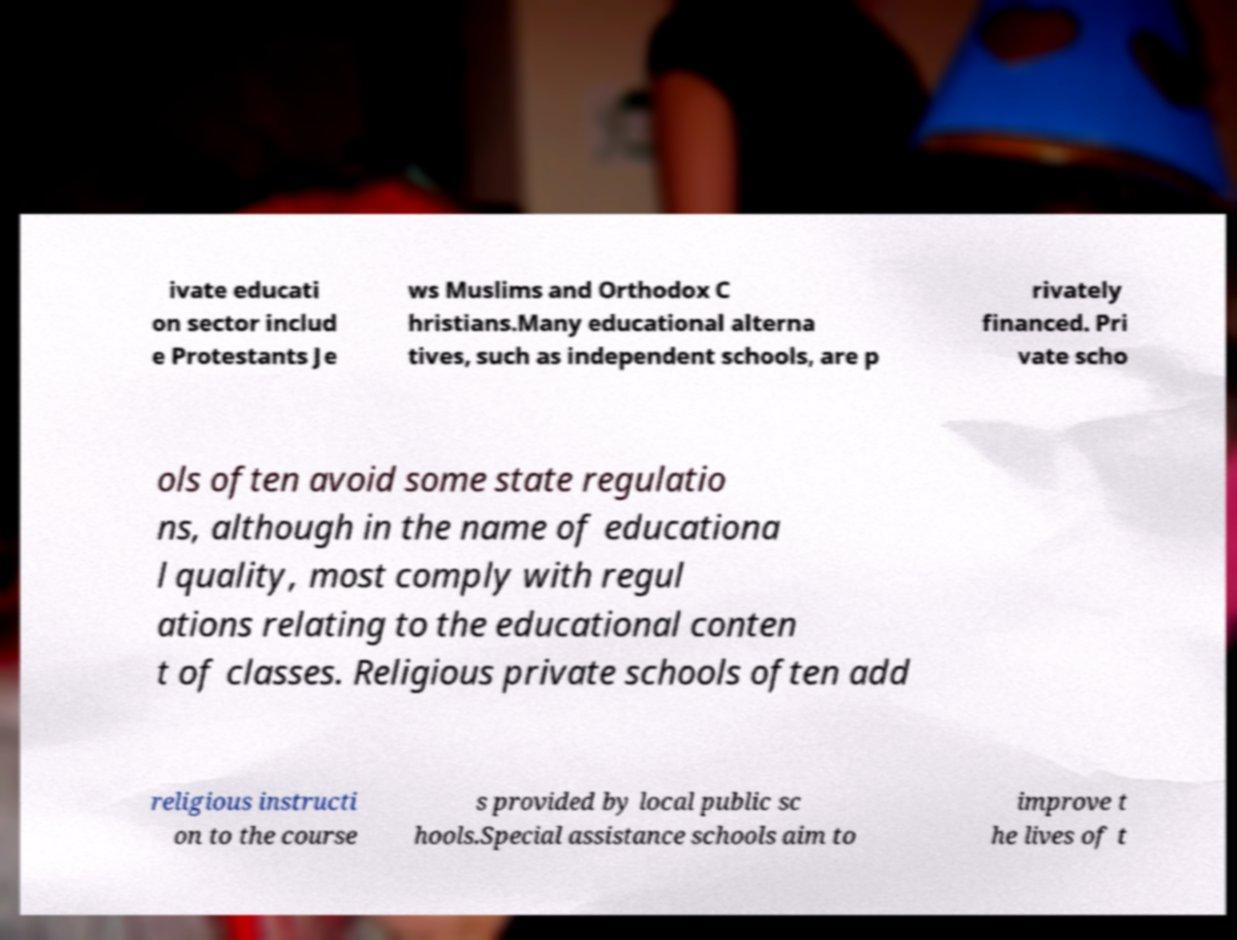There's text embedded in this image that I need extracted. Can you transcribe it verbatim? ivate educati on sector includ e Protestants Je ws Muslims and Orthodox C hristians.Many educational alterna tives, such as independent schools, are p rivately financed. Pri vate scho ols often avoid some state regulatio ns, although in the name of educationa l quality, most comply with regul ations relating to the educational conten t of classes. Religious private schools often add religious instructi on to the course s provided by local public sc hools.Special assistance schools aim to improve t he lives of t 